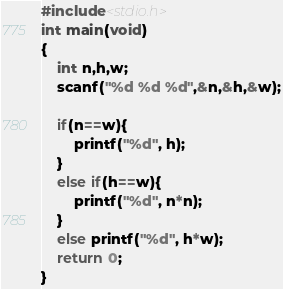<code> <loc_0><loc_0><loc_500><loc_500><_C_>#include<stdio.h>
int main(void)
{
	int n,h,w;
	scanf("%d %d %d",&n,&h,&w);

    if(n==w){
        printf("%d", h);
    }
    else if(h==w){
        printf("%d", n*n);
    }
    else printf("%d", h*w);
	return 0;
}</code> 